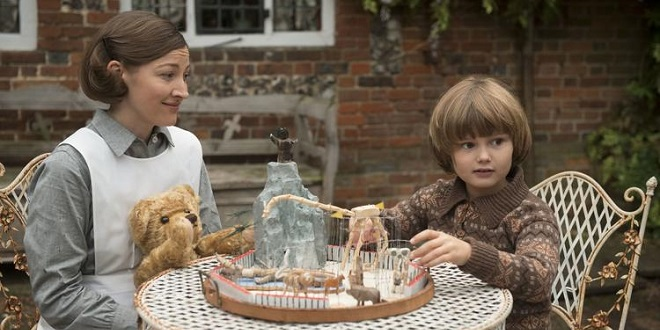Imagine if the teddy bear could talk, what would it say to the boy? If the teddy bear could talk, it might say: 'Hello there, young adventurer! I'm so happy to share this delightful moment with you. Your imagination is a wonderful place where endless adventures await. Let's embark on a journey together – just you, me, and our animal friends on this carousel. We'll explore places beyond your wildest dreams and have more fun than you can imagine. Remember, in your heart, your imagination can make anything possible!' Can you create a longer, more detailed conversation between the boy and the teddy bear? Boy: 'Hi there, Teddy! I love playing with you and my carousel. Do you think the animals ever get bored going around in circles?' 
Teddy Bear: 'Hello, my little friend! Oh, the animals never get bored. You see, in our carousel world, every turn brings a new adventure. When the carousel starts spinning, it transports us to different magical lands.' 
Boy: 'Really? Like where?' 
Teddy Bear: 'Well, just yesterday we visited the Land of Candy. There were lollipop trees, rivers of chocolate, and candy castles! The animals loved it, and so did I. We even had a parade with candy floats!’
Boy: 'That sounds amazing! What if I wanted to join you, where would we go next?' 
Teddy Bear: 'We can go anywhere you’d like! How about we visit the Island of Dinosaurs? We could ride on the back of a friendly dinosaur and explore ancient caves filled with glittering gems and fossils!' 
Boy: 'Yes! Let’s do that! Do we need to pack anything?' 
Teddy Bear: 'Just bring your adventurous spirit and your clever mind. With those, we can conquer any challenge and make every journey memorable. Are you ready, adventurer?' 
Boy: 'Absolutely! Let’s go, Teddy! Together we can do anything!' 